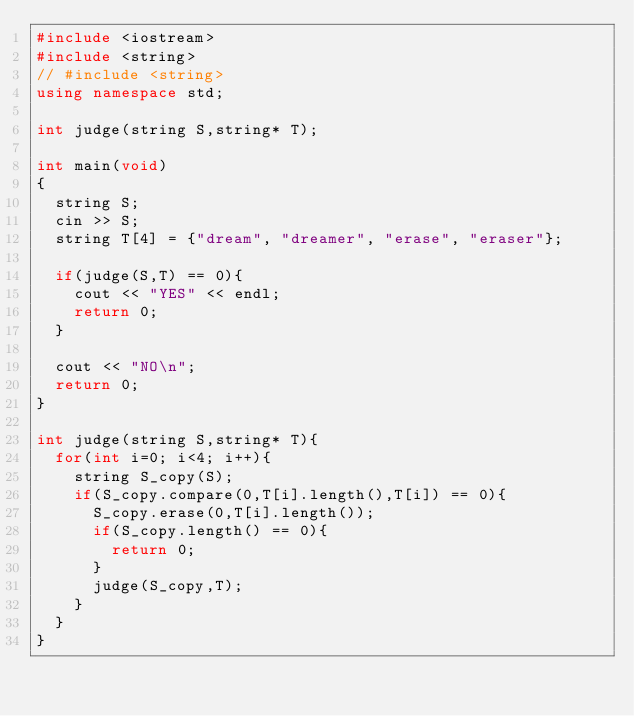Convert code to text. <code><loc_0><loc_0><loc_500><loc_500><_C++_>#include <iostream>
#include <string>
// #include <string>
using namespace std;

int judge(string S,string* T);

int main(void)
{
  string S;
  cin >> S;
  string T[4] = {"dream", "dreamer", "erase", "eraser"};

  if(judge(S,T) == 0){
    cout << "YES" << endl;
    return 0;
  }

  cout << "NO\n";
  return 0;
}

int judge(string S,string* T){
  for(int i=0; i<4; i++){
    string S_copy(S);
    if(S_copy.compare(0,T[i].length(),T[i]) == 0){
      S_copy.erase(0,T[i].length());
      if(S_copy.length() == 0){
        return 0;
      }
      judge(S_copy,T);
    }
  }
}
</code> 